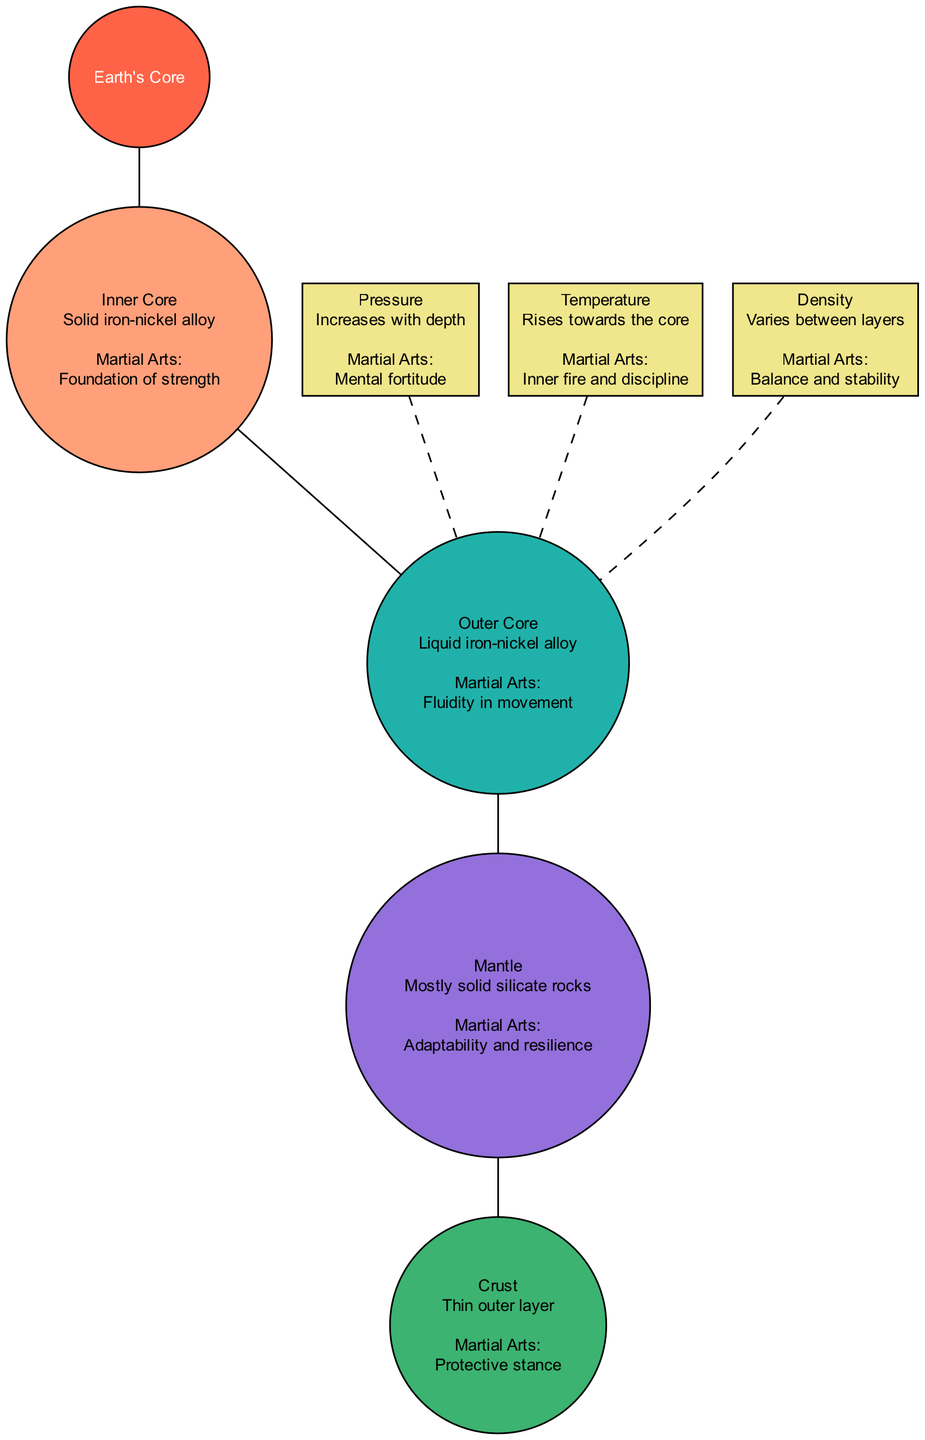What is the outermost layer of the Earth? The diagram identifies the "Crust" as the outermost layer, visually positioned at the top of the cross-section.
Answer: Crust Which layer is described as a "liquid iron-nickel alloy"? The "Outer Core" is the layer specifically described in the diagram with those characteristics, identified by its position following the Inner Core.
Answer: Outer Core What concept increases with depth in the Earth? The diagram mentions "Pressure" as the concept that increases with depth, making it evident by its direct labeling in the section about concepts.
Answer: Pressure How many layers are shown in the diagram? The diagram displays a total of four layers: Inner Core, Outer Core, Mantle, and Crust. The count can be determined by listing each labeled layer in the diagram.
Answer: Four Which layer is associated with "Adaptability and resilience"? The "Mantle" is the layer linked with this martial arts analogy, explicitly mentioned in the description in the diagram's layer details.
Answer: Mantle What physical characteristic rises toward the core? The diagram states that "Temperature" is the characteristic that increases as one moves toward the core, found under the concepts section.
Answer: Temperature Identify the relationship between Density and martial arts. The diagram connects "Density" with "Balance and stability", indicating how this geological concept is metaphorically tied to martial arts principles within the description.
Answer: Balance and stability What is the temperature description for the Earth closer to the core? It is described as "Rises towards the core," indicating how temperature behaves in relation to the Earth's structure displayed in the diagram.
Answer: Rises towards the core Which layer provides a "Protective stance"? The diagram describes the "Crust" as the layer that offers a protective stance, making this correlation clear in the martial arts relation provided.
Answer: Crust 